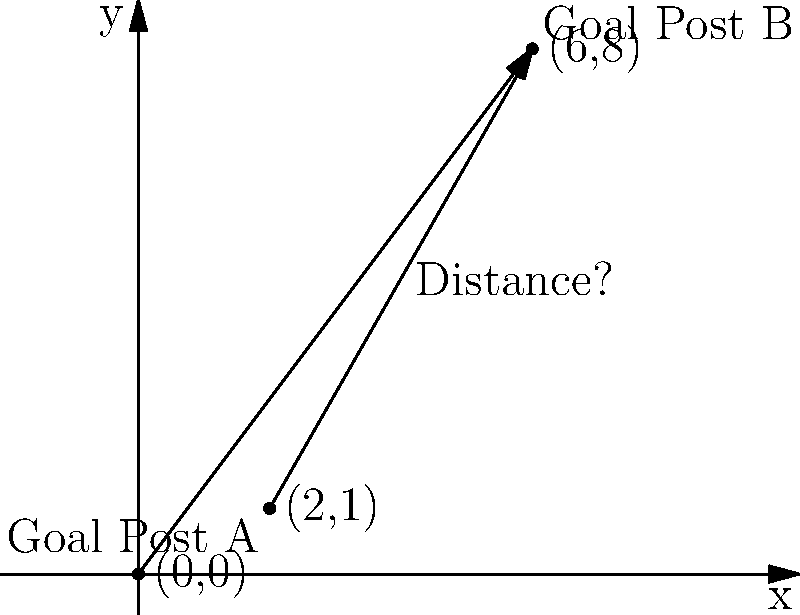Howdy, partner! Remember those days reportin' on local football games? Well, let's put that knowledge to use. On this here coordinate plane, we've got two goal posts: Goal Post A at (2,1) and Goal Post B at (6,8). Using the distance formula, can you calculate how far apart these posts are? Round your answer to the nearest yard, assumin' each unit represents 1 yard. Alright, let's break this down step by step:

1) The distance formula between two points $(x_1, y_1)$ and $(x_2, y_2)$ is:

   $$d = \sqrt{(x_2-x_1)^2 + (y_2-y_1)^2}$$

2) In our case:
   - Goal Post A: $(x_1, y_1) = (2, 1)$
   - Goal Post B: $(x_2, y_2) = (6, 8)$

3) Let's plug these into our formula:

   $$d = \sqrt{(6-2)^2 + (8-1)^2}$$

4) Simplify inside the parentheses:

   $$d = \sqrt{4^2 + 7^2}$$

5) Calculate the squares:

   $$d = \sqrt{16 + 49}$$

6) Add inside the square root:

   $$d = \sqrt{65}$$

7) Calculate the square root:

   $$d \approx 8.06225774829$$

8) Rounding to the nearest yard:

   $$d \approx 8 \text{ yards}$$

So, the distance between the goal posts is approximately 8 yards.
Answer: 8 yards 